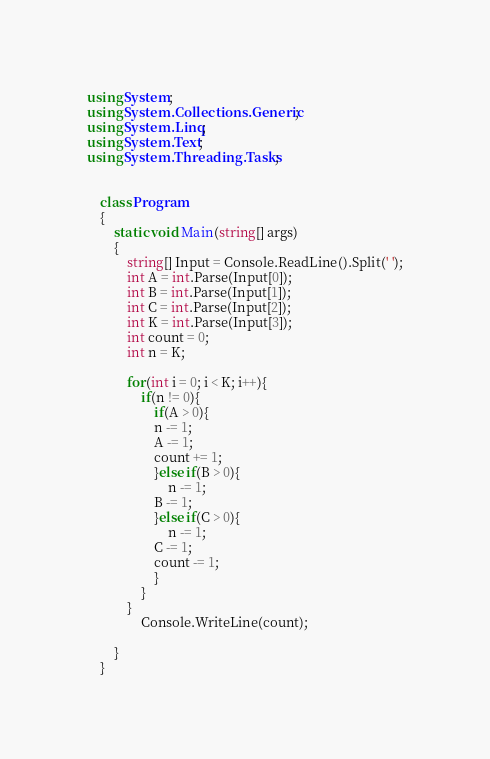Convert code to text. <code><loc_0><loc_0><loc_500><loc_500><_C#_>using System;
using System.Collections.Generic;
using System.Linq;
using System.Text;
using System.Threading.Tasks;


    class Program
    {
        static void Main(string[] args)
        {
            string[] Input = Console.ReadLine().Split(' ');
            int A = int.Parse(Input[0]);
            int B = int.Parse(Input[1]);
            int C = int.Parse(Input[2]);
            int K = int.Parse(Input[3]);
            int count = 0;
            int n = K;
            
            for(int i = 0; i < K; i++){
                if(n != 0){
                    if(A > 0){
                    n -= 1;
                    A -= 1;
                    count += 1;
                    }else if(B > 0){
                        n -= 1;
                    B -= 1;
                    }else if(C > 0){
                        n -= 1;
                    C -= 1;
                    count -= 1;
                    }
                }
            }
                Console.WriteLine(count);
            
        }
    }</code> 